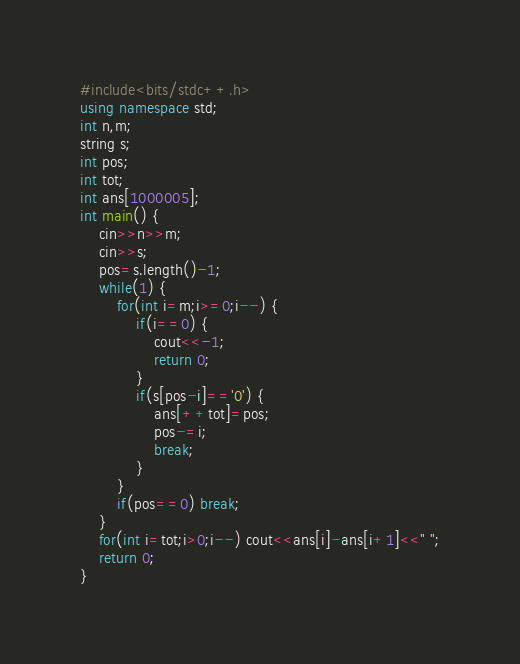<code> <loc_0><loc_0><loc_500><loc_500><_C++_>#include<bits/stdc++.h>
using namespace std;
int n,m;
string s;
int pos;
int tot;
int ans[1000005];
int main() {
	cin>>n>>m;
	cin>>s;
	pos=s.length()-1;
	while(1) {
		for(int i=m;i>=0;i--) {
			if(i==0) {
				cout<<-1;
				return 0;
			}
			if(s[pos-i]=='0') {
				ans[++tot]=pos;
				pos-=i;
				break;
			}
		}
		if(pos==0) break;
	}
	for(int i=tot;i>0;i--) cout<<ans[i]-ans[i+1]<<" ";
	return 0;
}</code> 